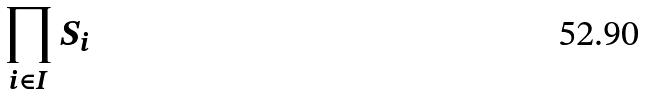<formula> <loc_0><loc_0><loc_500><loc_500>\prod _ { i \in I } S _ { i }</formula> 